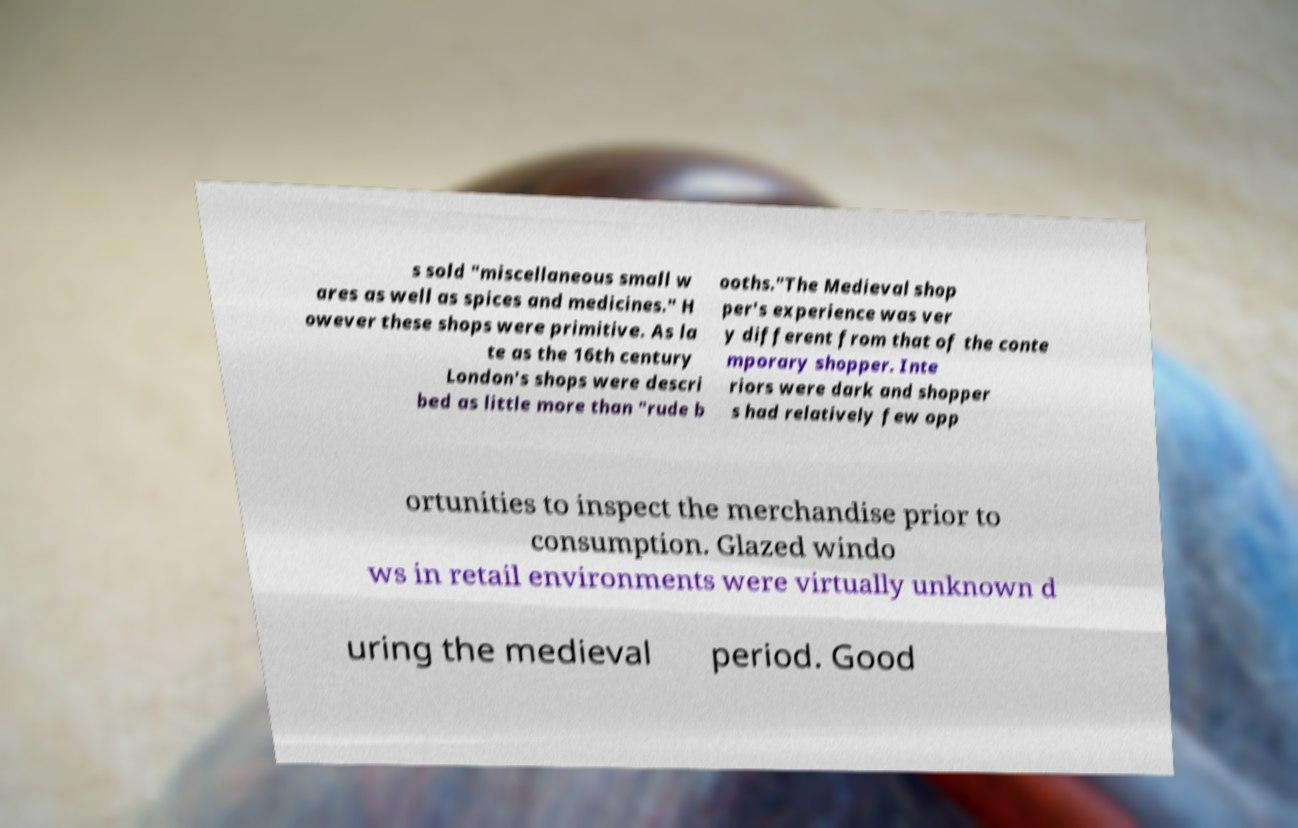What messages or text are displayed in this image? I need them in a readable, typed format. s sold "miscellaneous small w ares as well as spices and medicines." H owever these shops were primitive. As la te as the 16th century London's shops were descri bed as little more than "rude b ooths."The Medieval shop per's experience was ver y different from that of the conte mporary shopper. Inte riors were dark and shopper s had relatively few opp ortunities to inspect the merchandise prior to consumption. Glazed windo ws in retail environments were virtually unknown d uring the medieval period. Good 